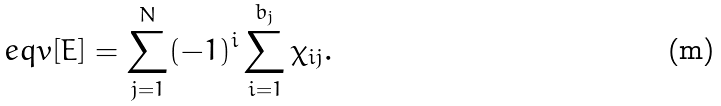<formula> <loc_0><loc_0><loc_500><loc_500>\ e q v { [ E ] } = \sum _ { j = 1 } ^ { N } ( - 1 ) ^ { i } \sum _ { i = 1 } ^ { b _ { j } } \chi _ { i j } .</formula> 